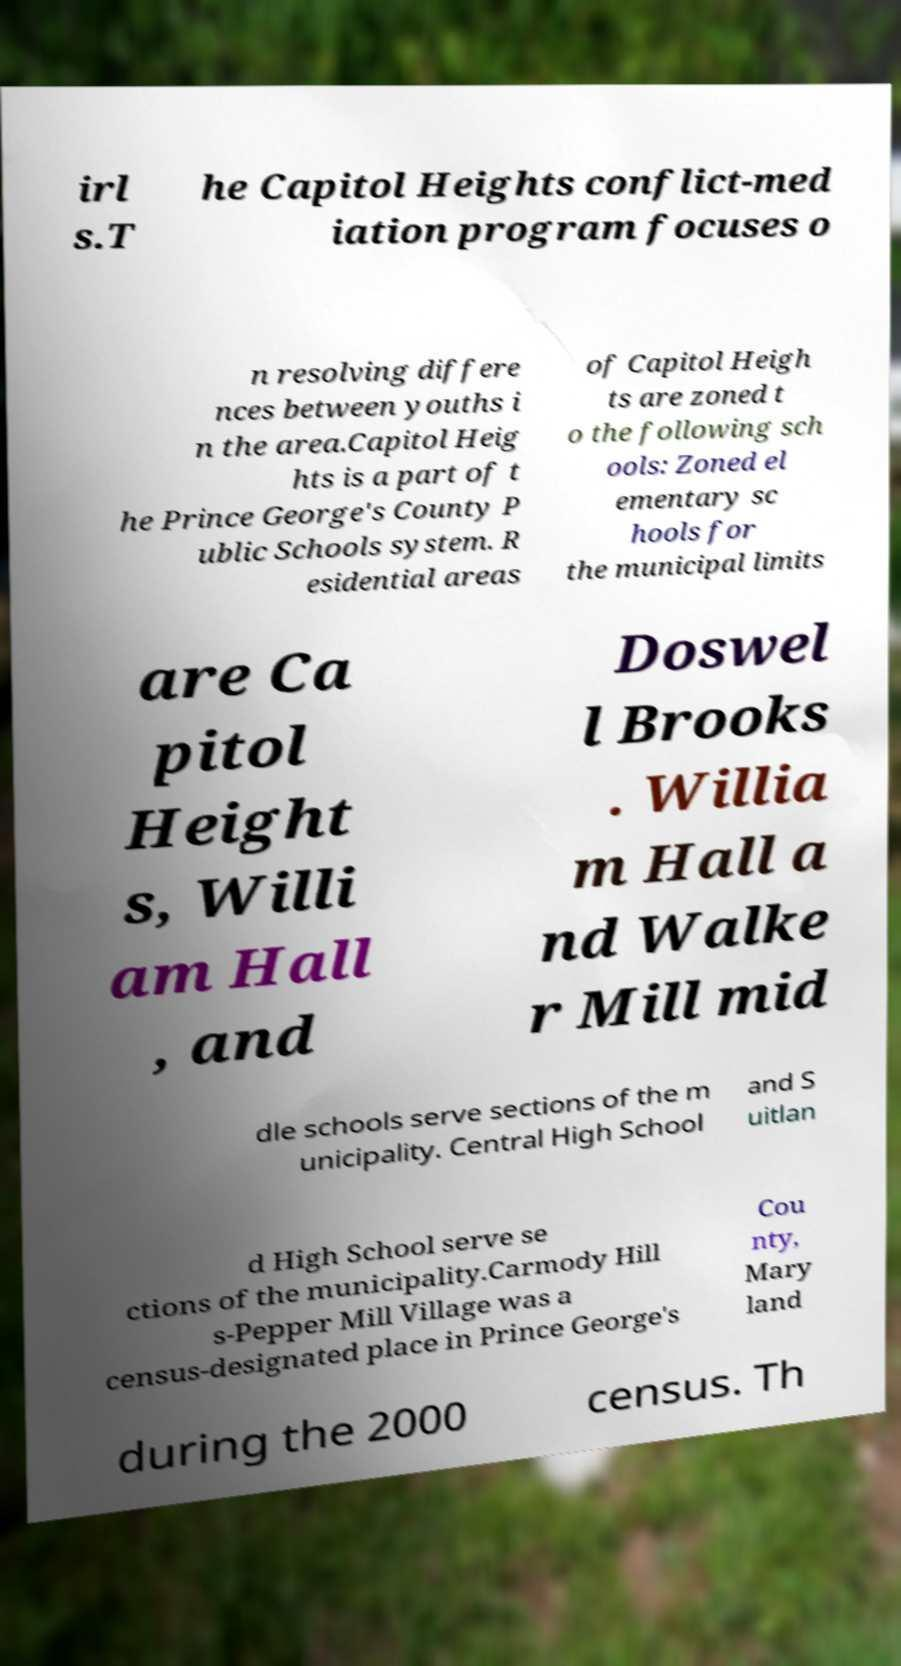What messages or text are displayed in this image? I need them in a readable, typed format. irl s.T he Capitol Heights conflict-med iation program focuses o n resolving differe nces between youths i n the area.Capitol Heig hts is a part of t he Prince George's County P ublic Schools system. R esidential areas of Capitol Heigh ts are zoned t o the following sch ools: Zoned el ementary sc hools for the municipal limits are Ca pitol Height s, Willi am Hall , and Doswel l Brooks . Willia m Hall a nd Walke r Mill mid dle schools serve sections of the m unicipality. Central High School and S uitlan d High School serve se ctions of the municipality.Carmody Hill s-Pepper Mill Village was a census-designated place in Prince George's Cou nty, Mary land during the 2000 census. Th 